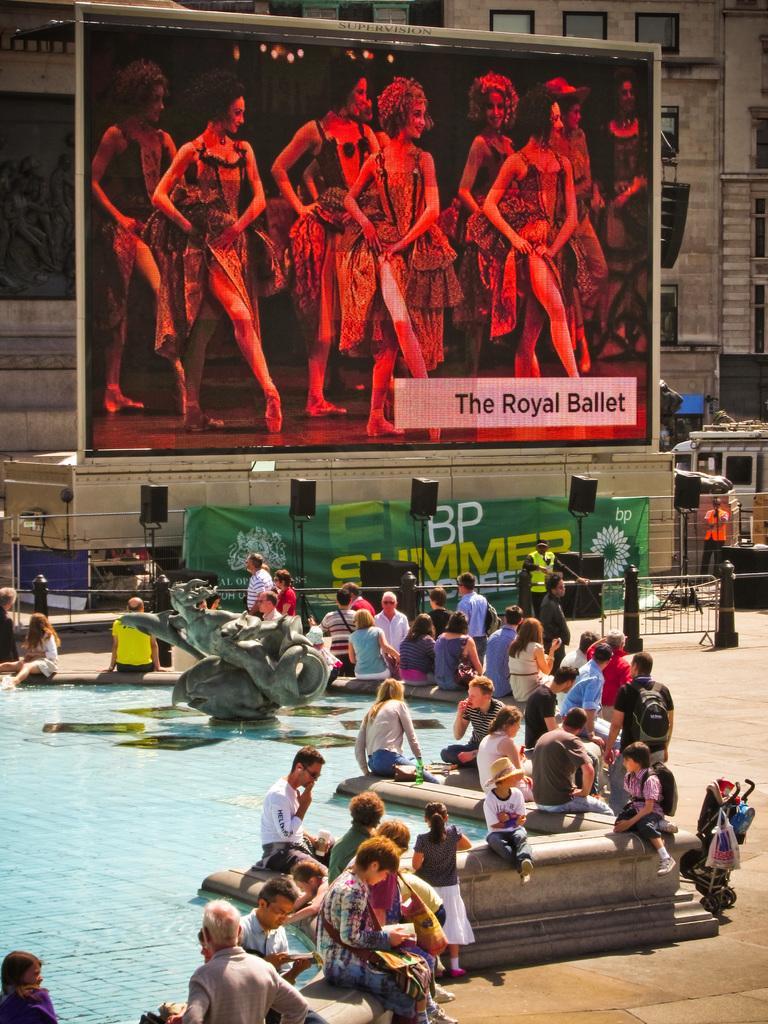Describe this image in one or two sentences. Here we can see a group of people, water and sculpture. Background there are hoardings and speakers. To this building there are glass windows. 